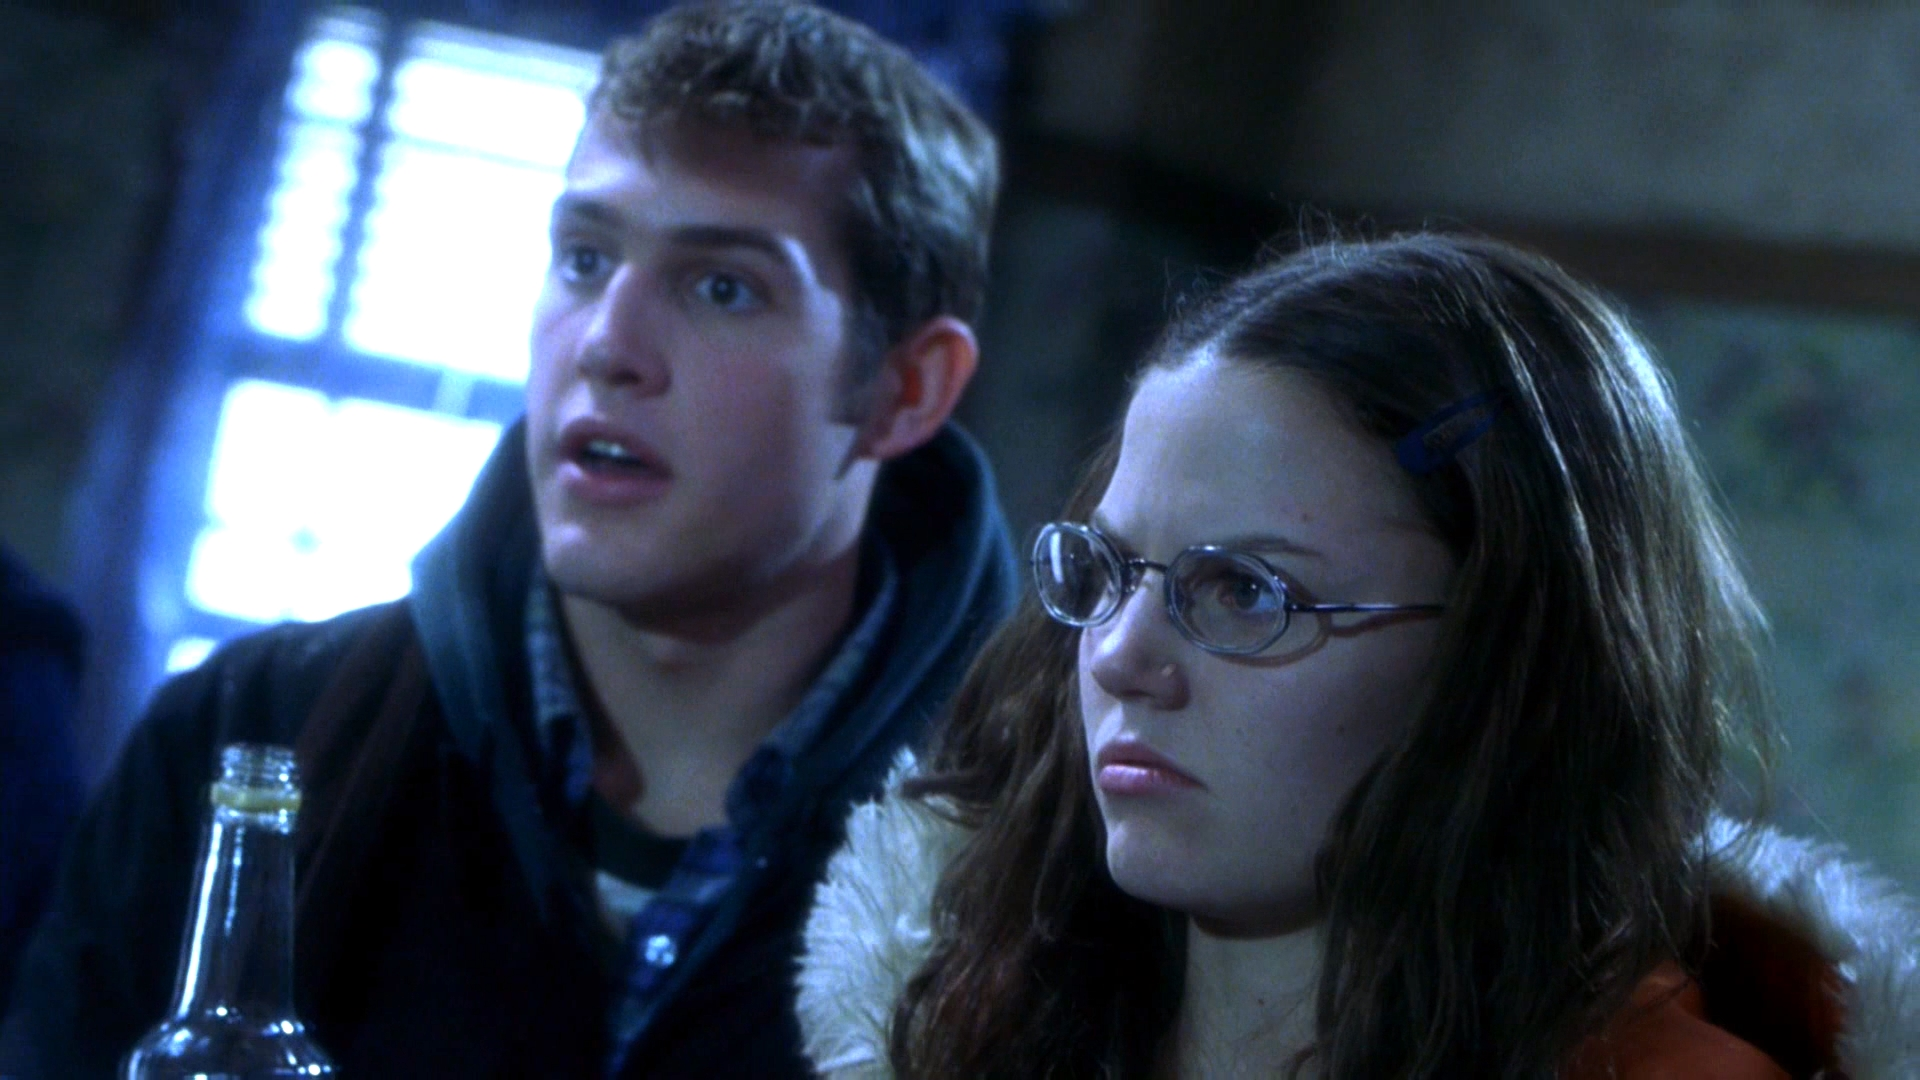What could have caused their expressions of shock in this image? Their expressions might indicate that they have just received some surprising news or witnessed an unexpected event within their environment. This could be a sudden revelation or a critical incident that significantly impacts their situation or the storyline if this is part of a TV show or movie. 